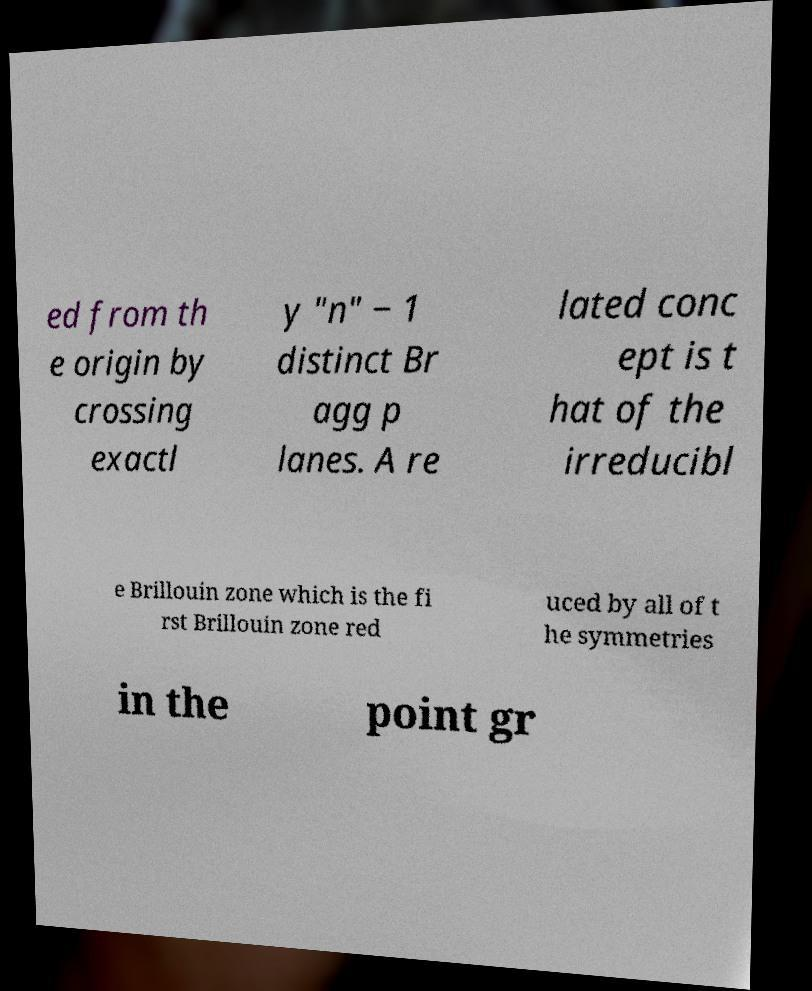I need the written content from this picture converted into text. Can you do that? ed from th e origin by crossing exactl y "n" − 1 distinct Br agg p lanes. A re lated conc ept is t hat of the irreducibl e Brillouin zone which is the fi rst Brillouin zone red uced by all of t he symmetries in the point gr 